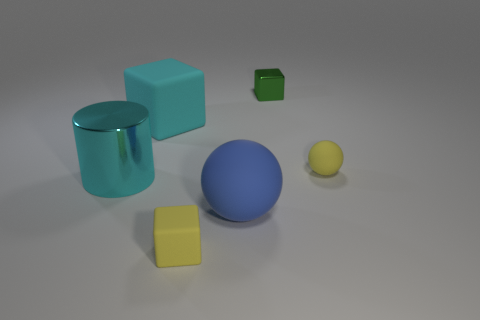There is a thing that is made of the same material as the big cyan cylinder; what size is it?
Your response must be concise. Small. There is a yellow rubber cube; are there any shiny objects in front of it?
Offer a very short reply. No. Are there any tiny yellow cubes that are on the right side of the yellow rubber object that is behind the big metallic cylinder?
Your answer should be compact. No. There is a yellow thing on the left side of the big blue matte ball; is its size the same as the ball that is in front of the cyan metal object?
Keep it short and to the point. No. What number of big things are either cyan matte objects or yellow objects?
Your answer should be compact. 1. What is the material of the small yellow object that is on the left side of the large matte object that is to the right of the cyan matte object?
Offer a terse response. Rubber. What is the shape of the object that is the same color as the big block?
Make the answer very short. Cylinder. Is there a red ball made of the same material as the cyan block?
Offer a terse response. No. Are the green object and the sphere right of the large sphere made of the same material?
Your answer should be compact. No. The ball that is the same size as the yellow rubber cube is what color?
Give a very brief answer. Yellow. 